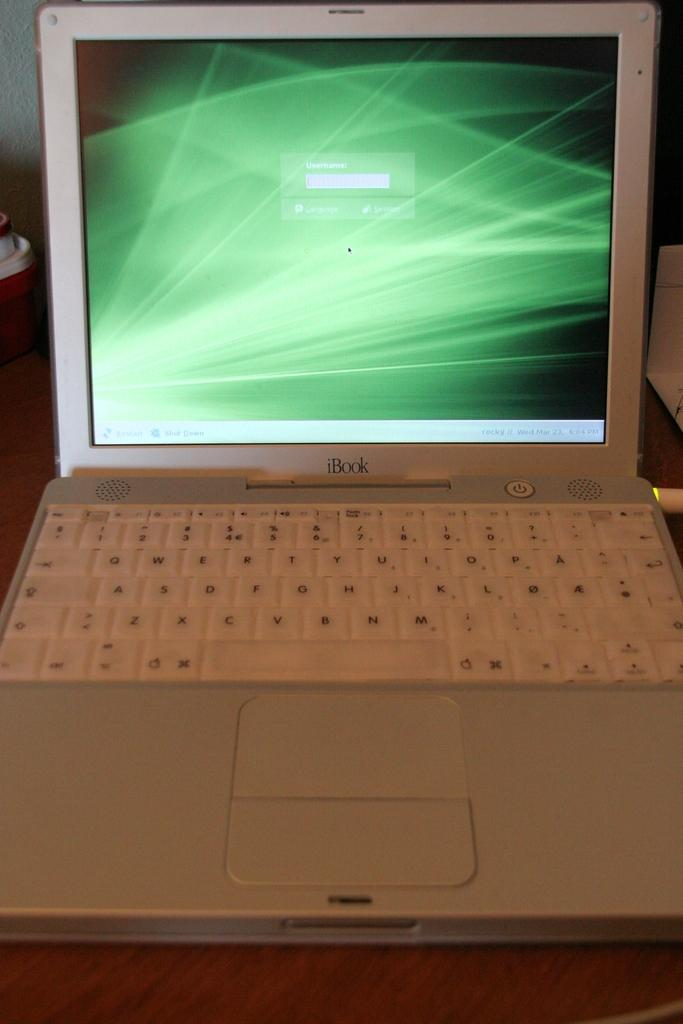<image>
Summarize the visual content of the image. An old school iBook laptop computer that is open. 